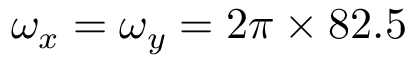Convert formula to latex. <formula><loc_0><loc_0><loc_500><loc_500>\omega _ { x } = \omega _ { y } = 2 \pi \times 8 2 . 5</formula> 